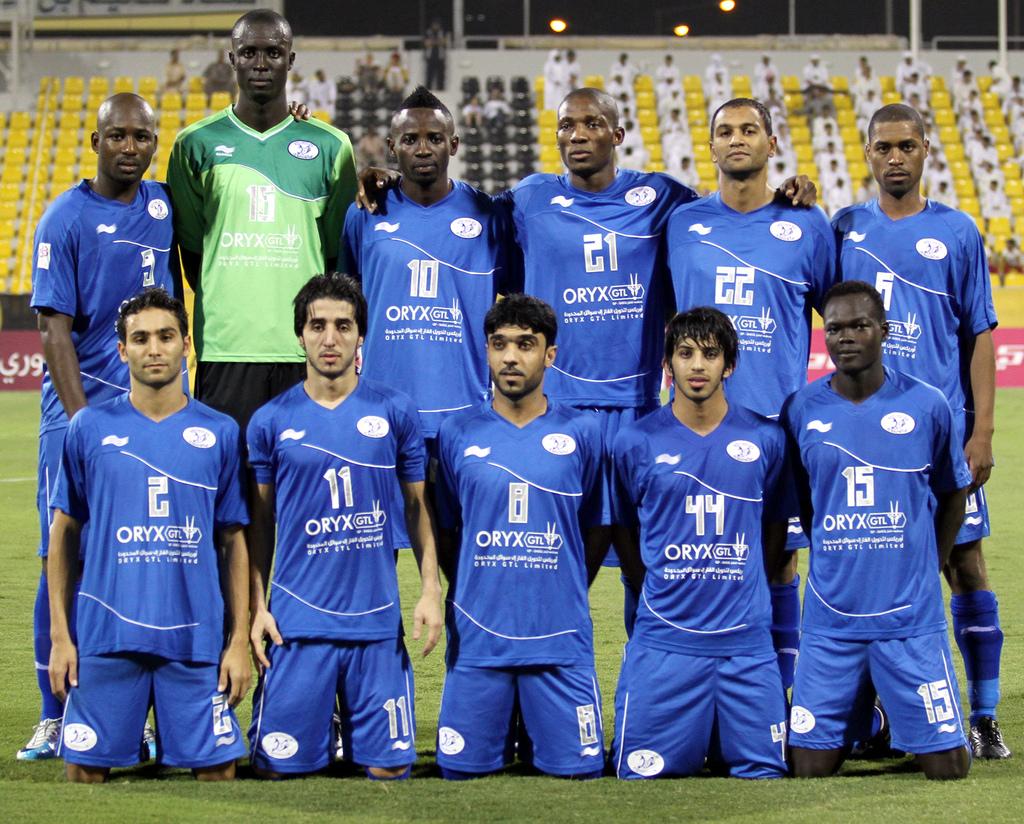What team are they on?
Offer a terse response. Oryx. What is the name of the company sponsoring the team?
Keep it short and to the point. Oryx. 